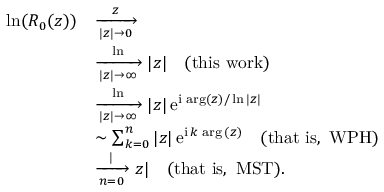<formula> <loc_0><loc_0><loc_500><loc_500>\begin{array} { r l } { \ln ( R _ { 0 } ( z ) ) } & { \xrightarrow [ | z | \to 0 ] z } \\ & { \xrightarrow [ | z | \to \infty ] \ln | z | \quad ( t h i s w o r k ) } \\ & { \xrightarrow [ | z | \to \infty ] \ln | z | \, e ^ { i \, \arg ( z ) / \ln | z | } } \\ & { \sim \sum _ { k = 0 } ^ { n } { | z | \, e ^ { i \, k \, \arg { ( z ) } } } \quad ( t h a t i s , W P H ) } \\ & { \xrightarrow [ n = 0 ] | z | \quad ( t h a t i s , M S T ) . } \end{array}</formula> 